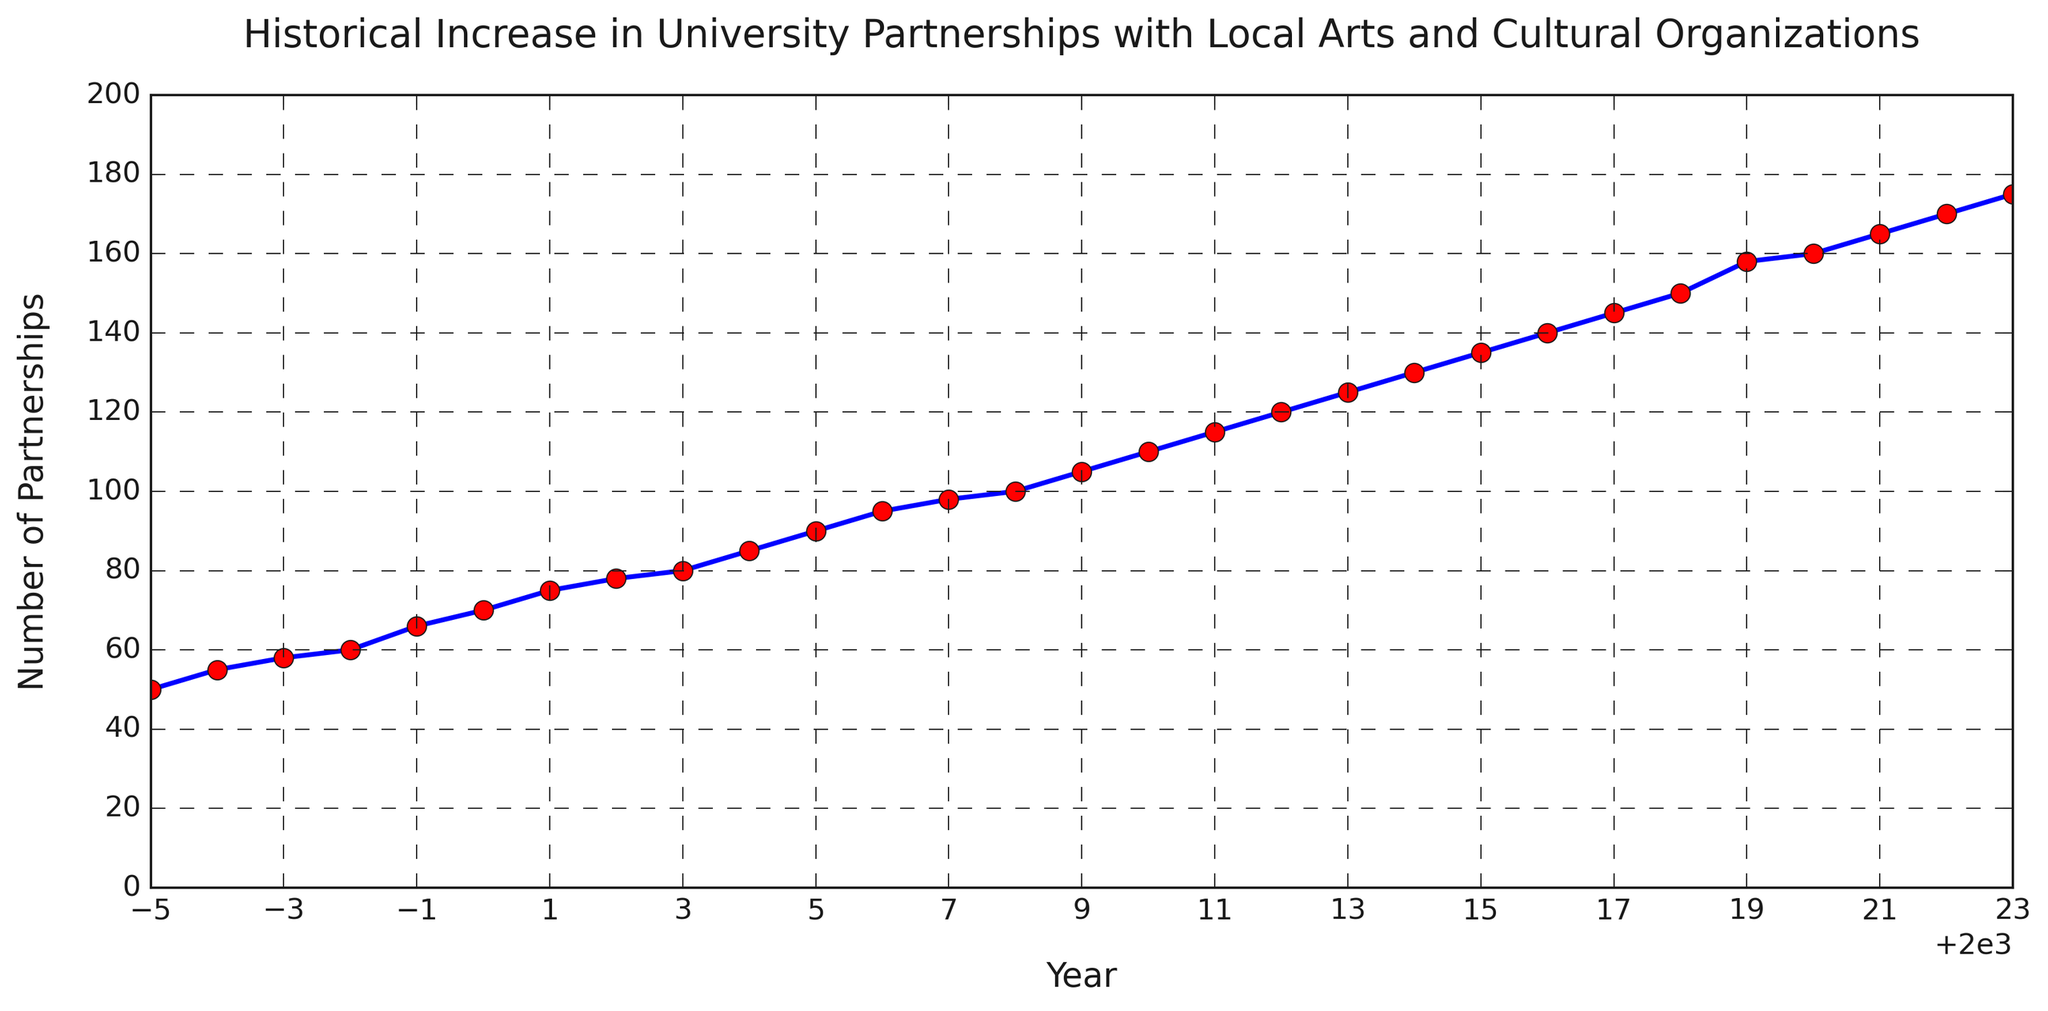What is the number of university partnerships in the year 2000? Find the year 2000 on the x-axis, then read the corresponding value on the y-axis, which indicates around 70 partnerships.
Answer: 70 What is the average number of partnerships between 1995 and 2000? Sum the number of partnerships from 1995 (50) to 2000 (70), then divide by the number of years (6). Calculation: (50 + 55 + 58 + 60 + 66 + 70) / 6 = 359 / 6 ≈ 59.83
Answer: 59.83 Did the number of university partnerships ever decline between 1995 and 2023? Look at the trend line on the plot; it shows a consistent increase every year, indicating no decline.
Answer: No By how many partnerships did the number increase from 2010 to 2015? Check the value in 2010 (110) and 2015 (135), then subtract the former from the latter: 135 - 110 = 25.
Answer: 25 Which year saw the fastest growth in university partnerships, based on the steepness of the line? Find the segment of the line with the steepest incline. The time around 1999 to 2000 and 2018 to 2019 seems the steepest. Approximate calculation shows both these periods show a steep increase.
Answer: 1999-2000 or 2018-2019 Compare the number of partnerships in 1995 and 2023. By what factor did the number increase? The number of partnerships in 1995 is 50, and in 2023 it's 175. The factor of increase is 175 / 50 = 3.5.
Answer: 3.5 Is the number of partnerships in 2020 more than twice the number of partnerships in 2000? Check the values: 2020 (160) and 2000 (70). Then compare if 160 is more than twice of 70: 70 * 2 = 140, and 160 > 140.
Answer: Yes What is the median number of partnerships from 1995 to 2023? Arrange the number of partnerships in ascending order and find the middle value. With 29 data points, the median is the 15th value: 115 (year 2011).
Answer: 115 